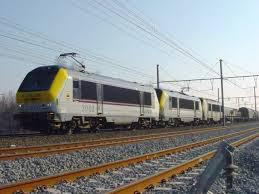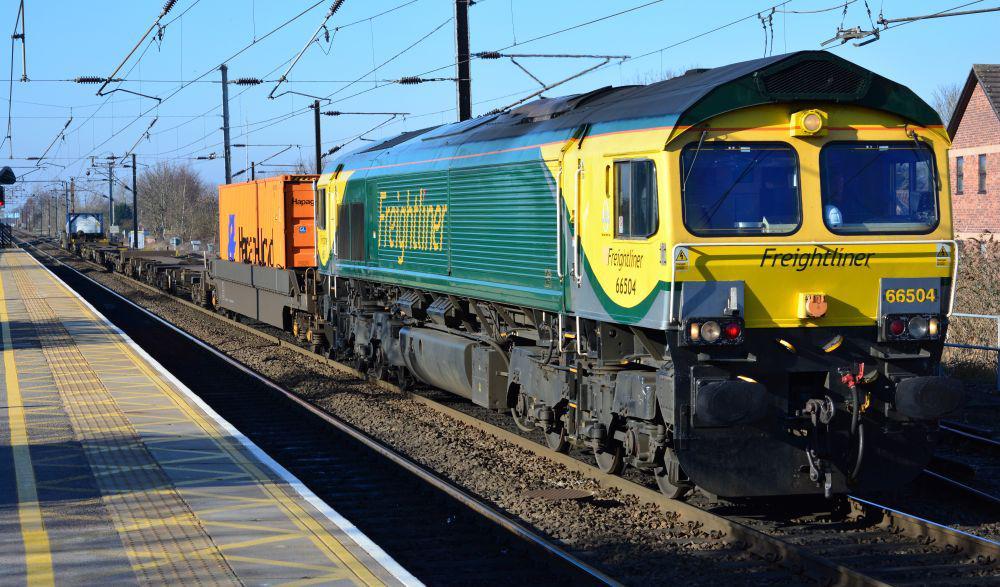The first image is the image on the left, the second image is the image on the right. Given the left and right images, does the statement "The train in the image to the right features a fair amount of green paint." hold true? Answer yes or no. Yes. The first image is the image on the left, the second image is the image on the right. Analyze the images presented: Is the assertion "At least one train has a visibly sloped front with a band of solid color around the windshield." valid? Answer yes or no. Yes. 